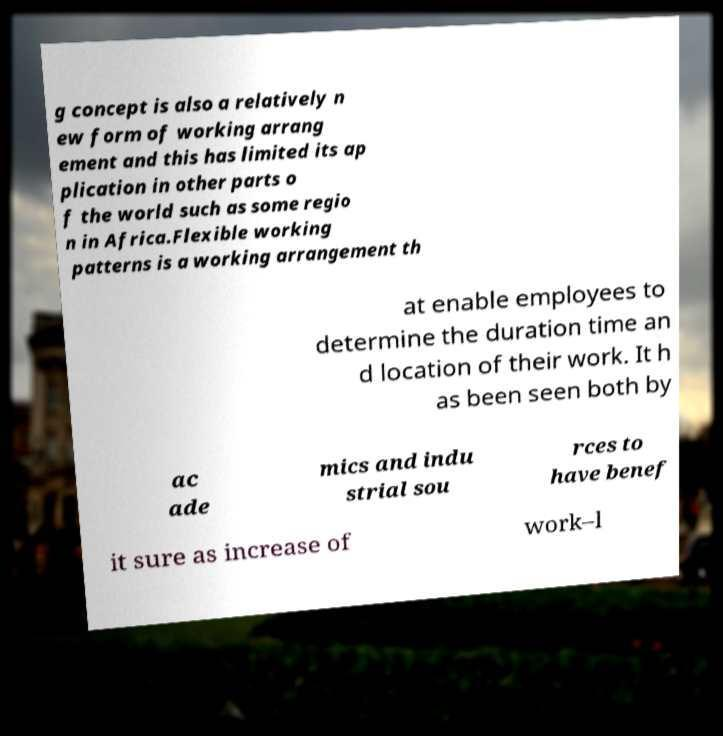I need the written content from this picture converted into text. Can you do that? g concept is also a relatively n ew form of working arrang ement and this has limited its ap plication in other parts o f the world such as some regio n in Africa.Flexible working patterns is a working arrangement th at enable employees to determine the duration time an d location of their work. It h as been seen both by ac ade mics and indu strial sou rces to have benef it sure as increase of work–l 